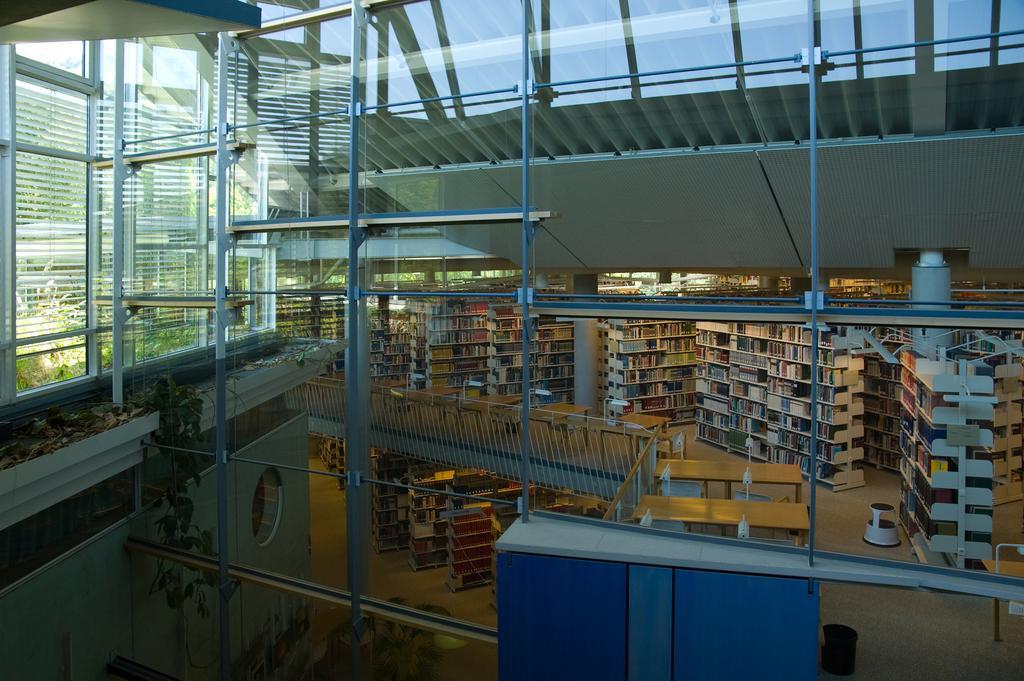In one or two sentences, can you explain what this image depicts? In this image we can see books arranged in racks. There is a glass wall. There are rods. To the left side of the image there is wall. 